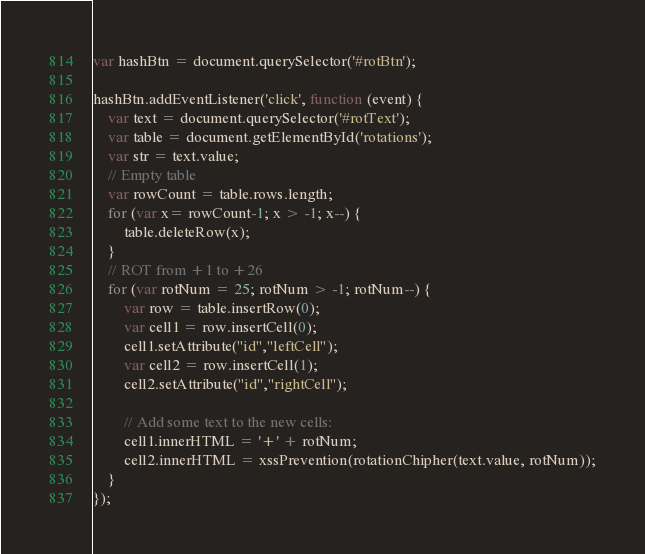<code> <loc_0><loc_0><loc_500><loc_500><_JavaScript_>var hashBtn = document.querySelector('#rotBtn');

hashBtn.addEventListener('click', function (event) {
	var text = document.querySelector('#rotText');
    var table = document.getElementById('rotations');
    var str = text.value;
    // Empty table
    var rowCount = table.rows.length;
    for (var x= rowCount-1; x > -1; x--) {
        table.deleteRow(x);
    }
    // ROT from +1 to +26
    for (var rotNum = 25; rotNum > -1; rotNum--) {
        var row = table.insertRow(0);
        var cell1 = row.insertCell(0);
        cell1.setAttribute("id","leftCell");
        var cell2 = row.insertCell(1);
        cell2.setAttribute("id","rightCell");

        // Add some text to the new cells:
        cell1.innerHTML = '+' + rotNum;
        cell2.innerHTML = xssPrevention(rotationChipher(text.value, rotNum));
    }
});</code> 